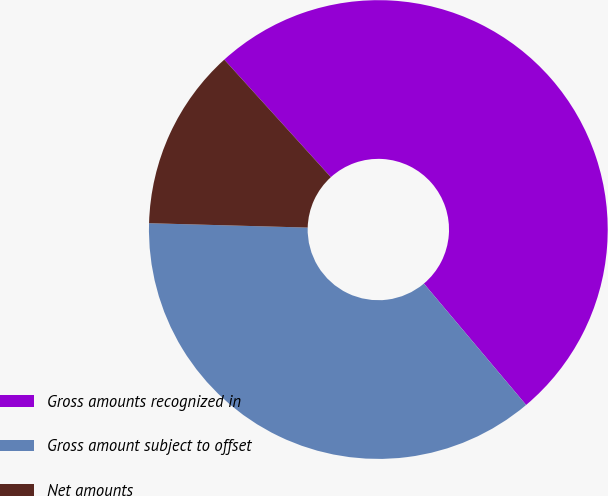Convert chart. <chart><loc_0><loc_0><loc_500><loc_500><pie_chart><fcel>Gross amounts recognized in<fcel>Gross amount subject to offset<fcel>Net amounts<nl><fcel>50.58%<fcel>36.58%<fcel>12.84%<nl></chart> 